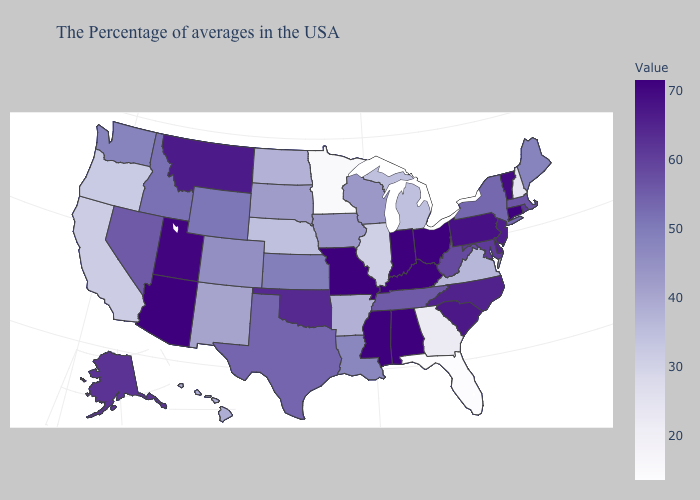Does the map have missing data?
Keep it brief. No. Does Washington have the highest value in the USA?
Answer briefly. No. Does North Dakota have the highest value in the USA?
Short answer required. No. Which states hav the highest value in the West?
Be succinct. Arizona. Does Idaho have the lowest value in the West?
Be succinct. No. Which states have the lowest value in the USA?
Give a very brief answer. Florida. Which states have the highest value in the USA?
Answer briefly. Connecticut, Ohio, Kentucky, Indiana, Alabama, Mississippi, Missouri, Arizona. 